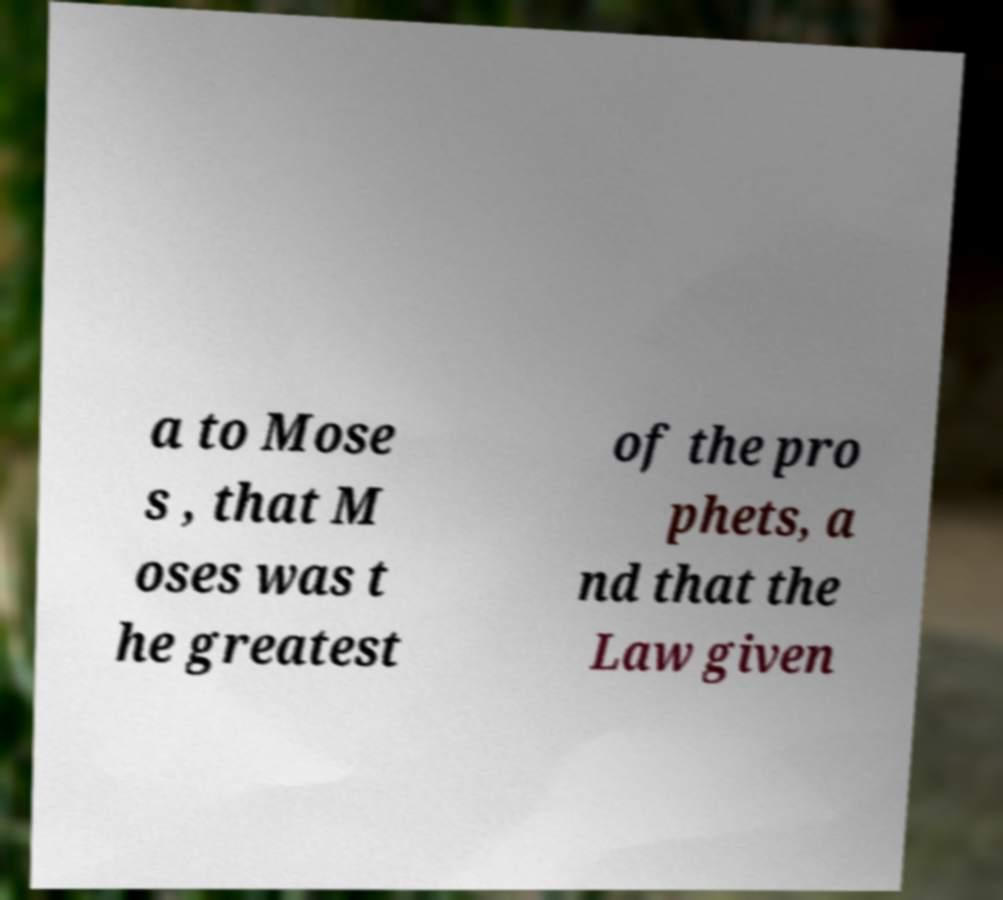Please identify and transcribe the text found in this image. a to Mose s , that M oses was t he greatest of the pro phets, a nd that the Law given 